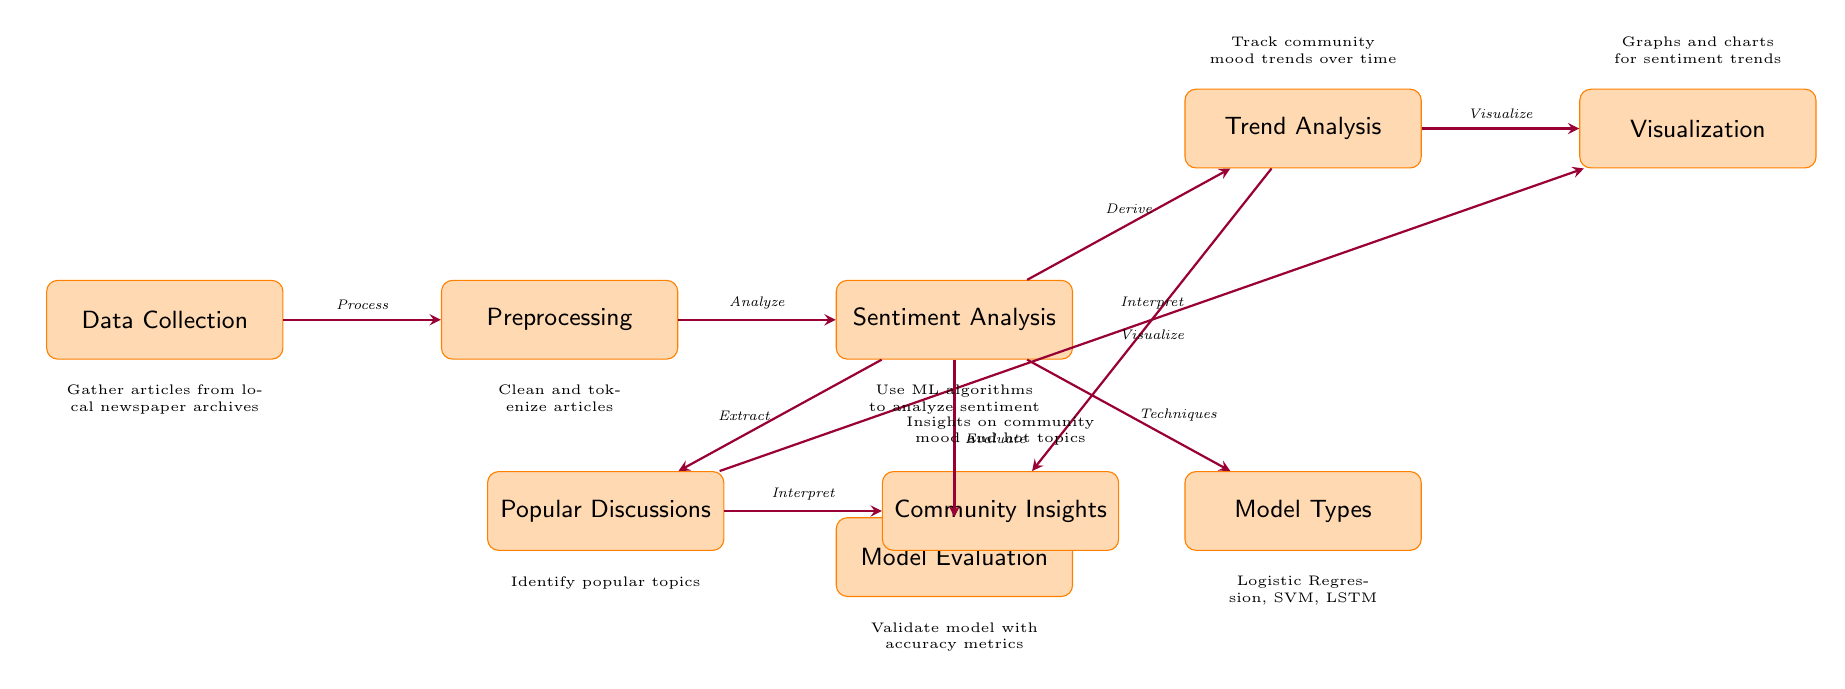What is the first step in the diagram? The first step in the diagram is "Data Collection," which is the node on the far left. This indicates the starting point of the sentiment analysis process.
Answer: Data Collection How many main processes are outlined in the diagram? The diagram contains seven main processes, which are represented by the nodes from "Data Collection" to "Model Evaluation."
Answer: Seven What type of model types are mentioned in the diagram? The model types listed in the diagram are "Logistic Regression, SVM, LSTM," which are shown as techniques used in the sentiment analysis.
Answer: Logistic Regression, SVM, LSTM Which process follows "Sentiment Analysis"? The process that follows "Sentiment Analysis" is "Model Evaluation," which is depicted directly below the "Sentiment Analysis" node.
Answer: Model Evaluation What is the relationship between "Trend Analysis" and "Visualization"? The relationship is that "Trend Analysis" leads to "Visualization," as indicated by an arrow pointing from "Trend Analysis" to "Visualization," representing that the trends are visualized.
Answer: Visualize What does the "Insights" process derive from? The "Insights" process derives from "Popular Discussions," as shown by the arrow indicating that insights come from interpreting popular topics discussed in the community.
Answer: Popular Discussions How is the model evaluated according to the diagram? The model is evaluated using "accuracy metrics," which are mentioned as part of the "Model Evaluation" step that assesses the performance of the sentiment analysis techniques.
Answer: Accuracy metrics What is the goal of "Trend Analysis"? The goal of "Trend Analysis" is to "Track community mood trends over time," which is specified directly above the corresponding node in the diagram.
Answer: Track community mood trends over time What does the "Data Collection" process specifically gather? The "Data Collection" process gathers "articles from local newspaper archives," which is explicitly noted below the "Data Collection" node.
Answer: Articles from local newspaper archives 